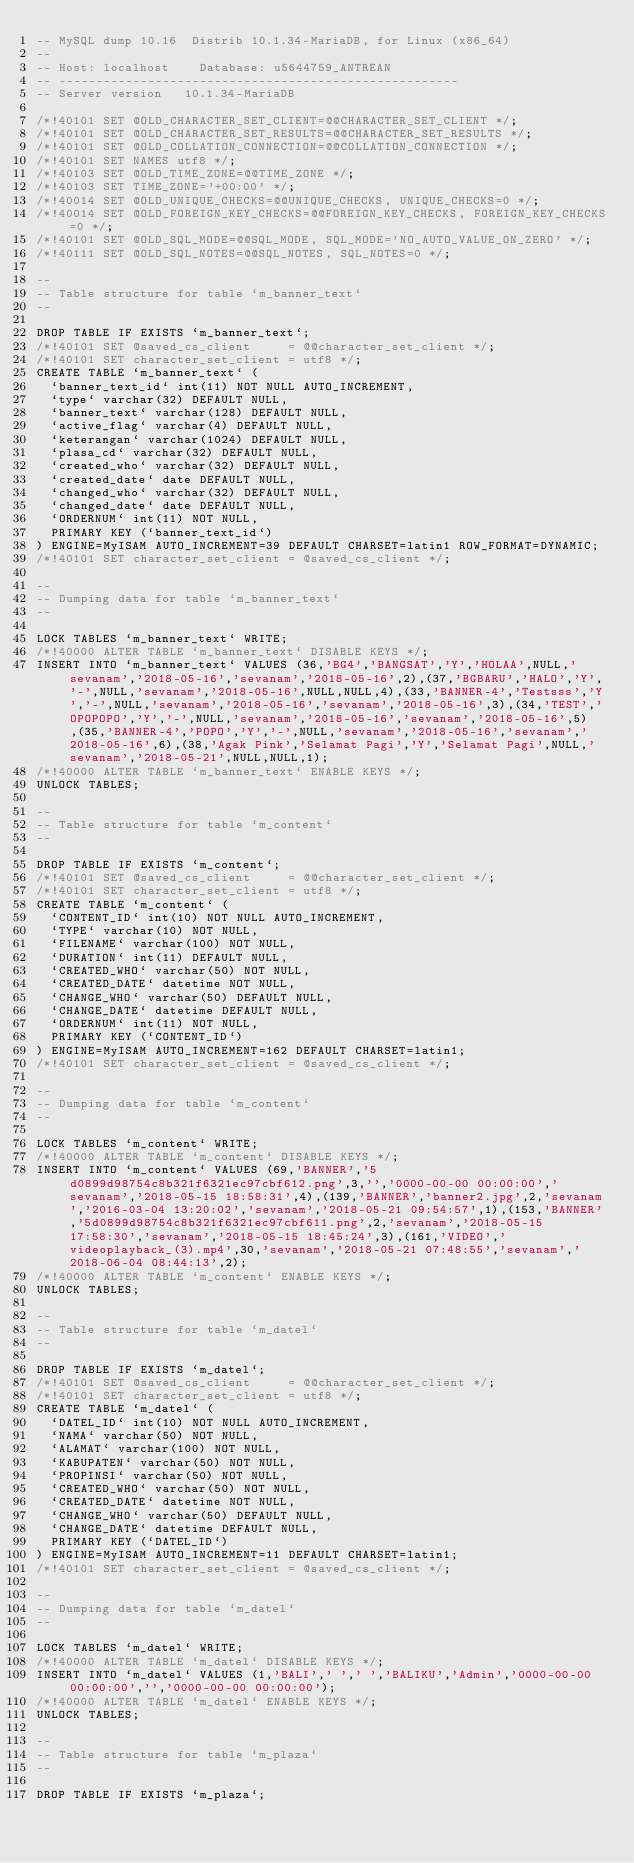<code> <loc_0><loc_0><loc_500><loc_500><_SQL_>-- MySQL dump 10.16  Distrib 10.1.34-MariaDB, for Linux (x86_64)
--
-- Host: localhost    Database: u5644759_ANTREAN
-- ------------------------------------------------------
-- Server version	10.1.34-MariaDB

/*!40101 SET @OLD_CHARACTER_SET_CLIENT=@@CHARACTER_SET_CLIENT */;
/*!40101 SET @OLD_CHARACTER_SET_RESULTS=@@CHARACTER_SET_RESULTS */;
/*!40101 SET @OLD_COLLATION_CONNECTION=@@COLLATION_CONNECTION */;
/*!40101 SET NAMES utf8 */;
/*!40103 SET @OLD_TIME_ZONE=@@TIME_ZONE */;
/*!40103 SET TIME_ZONE='+00:00' */;
/*!40014 SET @OLD_UNIQUE_CHECKS=@@UNIQUE_CHECKS, UNIQUE_CHECKS=0 */;
/*!40014 SET @OLD_FOREIGN_KEY_CHECKS=@@FOREIGN_KEY_CHECKS, FOREIGN_KEY_CHECKS=0 */;
/*!40101 SET @OLD_SQL_MODE=@@SQL_MODE, SQL_MODE='NO_AUTO_VALUE_ON_ZERO' */;
/*!40111 SET @OLD_SQL_NOTES=@@SQL_NOTES, SQL_NOTES=0 */;

--
-- Table structure for table `m_banner_text`
--

DROP TABLE IF EXISTS `m_banner_text`;
/*!40101 SET @saved_cs_client     = @@character_set_client */;
/*!40101 SET character_set_client = utf8 */;
CREATE TABLE `m_banner_text` (
  `banner_text_id` int(11) NOT NULL AUTO_INCREMENT,
  `type` varchar(32) DEFAULT NULL,
  `banner_text` varchar(128) DEFAULT NULL,
  `active_flag` varchar(4) DEFAULT NULL,
  `keterangan` varchar(1024) DEFAULT NULL,
  `plasa_cd` varchar(32) DEFAULT NULL,
  `created_who` varchar(32) DEFAULT NULL,
  `created_date` date DEFAULT NULL,
  `changed_who` varchar(32) DEFAULT NULL,
  `changed_date` date DEFAULT NULL,
  `ORDERNUM` int(11) NOT NULL,
  PRIMARY KEY (`banner_text_id`)
) ENGINE=MyISAM AUTO_INCREMENT=39 DEFAULT CHARSET=latin1 ROW_FORMAT=DYNAMIC;
/*!40101 SET character_set_client = @saved_cs_client */;

--
-- Dumping data for table `m_banner_text`
--

LOCK TABLES `m_banner_text` WRITE;
/*!40000 ALTER TABLE `m_banner_text` DISABLE KEYS */;
INSERT INTO `m_banner_text` VALUES (36,'BG4','BANGSAT','Y','HOLAA',NULL,'sevanam','2018-05-16','sevanam','2018-05-16',2),(37,'BGBARU','HALO','Y','-',NULL,'sevanam','2018-05-16',NULL,NULL,4),(33,'BANNER-4','Testsss','Y','-',NULL,'sevanam','2018-05-16','sevanam','2018-05-16',3),(34,'TEST','OPOPOPO','Y','-',NULL,'sevanam','2018-05-16','sevanam','2018-05-16',5),(35,'BANNER-4','POPO','Y','-',NULL,'sevanam','2018-05-16','sevanam','2018-05-16',6),(38,'Agak Pink','Selamat Pagi','Y','Selamat Pagi',NULL,'sevanam','2018-05-21',NULL,NULL,1);
/*!40000 ALTER TABLE `m_banner_text` ENABLE KEYS */;
UNLOCK TABLES;

--
-- Table structure for table `m_content`
--

DROP TABLE IF EXISTS `m_content`;
/*!40101 SET @saved_cs_client     = @@character_set_client */;
/*!40101 SET character_set_client = utf8 */;
CREATE TABLE `m_content` (
  `CONTENT_ID` int(10) NOT NULL AUTO_INCREMENT,
  `TYPE` varchar(10) NOT NULL,
  `FILENAME` varchar(100) NOT NULL,
  `DURATION` int(11) DEFAULT NULL,
  `CREATED_WHO` varchar(50) NOT NULL,
  `CREATED_DATE` datetime NOT NULL,
  `CHANGE_WHO` varchar(50) DEFAULT NULL,
  `CHANGE_DATE` datetime DEFAULT NULL,
  `ORDERNUM` int(11) NOT NULL,
  PRIMARY KEY (`CONTENT_ID`)
) ENGINE=MyISAM AUTO_INCREMENT=162 DEFAULT CHARSET=latin1;
/*!40101 SET character_set_client = @saved_cs_client */;

--
-- Dumping data for table `m_content`
--

LOCK TABLES `m_content` WRITE;
/*!40000 ALTER TABLE `m_content` DISABLE KEYS */;
INSERT INTO `m_content` VALUES (69,'BANNER','5d0899d98754c8b321f6321ec97cbf612.png',3,'','0000-00-00 00:00:00','sevanam','2018-05-15 18:58:31',4),(139,'BANNER','banner2.jpg',2,'sevanam','2016-03-04 13:20:02','sevanam','2018-05-21 09:54:57',1),(153,'BANNER','5d0899d98754c8b321f6321ec97cbf611.png',2,'sevanam','2018-05-15 17:58:30','sevanam','2018-05-15 18:45:24',3),(161,'VIDEO','videoplayback_(3).mp4',30,'sevanam','2018-05-21 07:48:55','sevanam','2018-06-04 08:44:13',2);
/*!40000 ALTER TABLE `m_content` ENABLE KEYS */;
UNLOCK TABLES;

--
-- Table structure for table `m_datel`
--

DROP TABLE IF EXISTS `m_datel`;
/*!40101 SET @saved_cs_client     = @@character_set_client */;
/*!40101 SET character_set_client = utf8 */;
CREATE TABLE `m_datel` (
  `DATEL_ID` int(10) NOT NULL AUTO_INCREMENT,
  `NAMA` varchar(50) NOT NULL,
  `ALAMAT` varchar(100) NOT NULL,
  `KABUPATEN` varchar(50) NOT NULL,
  `PROPINSI` varchar(50) NOT NULL,
  `CREATED_WHO` varchar(50) NOT NULL,
  `CREATED_DATE` datetime NOT NULL,
  `CHANGE_WHO` varchar(50) DEFAULT NULL,
  `CHANGE_DATE` datetime DEFAULT NULL,
  PRIMARY KEY (`DATEL_ID`)
) ENGINE=MyISAM AUTO_INCREMENT=11 DEFAULT CHARSET=latin1;
/*!40101 SET character_set_client = @saved_cs_client */;

--
-- Dumping data for table `m_datel`
--

LOCK TABLES `m_datel` WRITE;
/*!40000 ALTER TABLE `m_datel` DISABLE KEYS */;
INSERT INTO `m_datel` VALUES (1,'BALI',' ',' ','BALIKU','Admin','0000-00-00 00:00:00','','0000-00-00 00:00:00');
/*!40000 ALTER TABLE `m_datel` ENABLE KEYS */;
UNLOCK TABLES;

--
-- Table structure for table `m_plaza`
--

DROP TABLE IF EXISTS `m_plaza`;</code> 